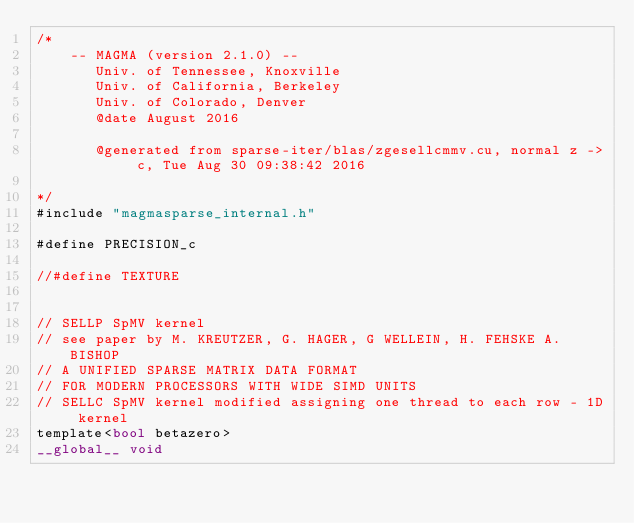Convert code to text. <code><loc_0><loc_0><loc_500><loc_500><_Cuda_>/*
    -- MAGMA (version 2.1.0) --
       Univ. of Tennessee, Knoxville
       Univ. of California, Berkeley
       Univ. of Colorado, Denver
       @date August 2016

       @generated from sparse-iter/blas/zgesellcmmv.cu, normal z -> c, Tue Aug 30 09:38:42 2016

*/
#include "magmasparse_internal.h"

#define PRECISION_c

//#define TEXTURE


// SELLP SpMV kernel
// see paper by M. KREUTZER, G. HAGER, G WELLEIN, H. FEHSKE A. BISHOP
// A UNIFIED SPARSE MATRIX DATA FORMAT 
// FOR MODERN PROCESSORS WITH WIDE SIMD UNITS
// SELLC SpMV kernel modified assigning one thread to each row - 1D kernel
template<bool betazero>
__global__ void </code> 